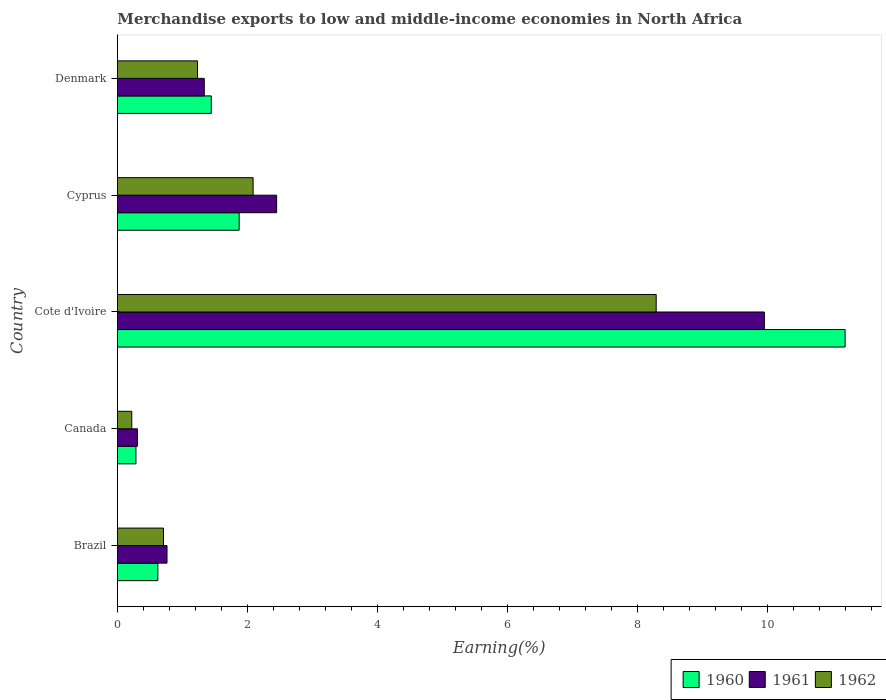How many different coloured bars are there?
Offer a very short reply. 3. How many bars are there on the 3rd tick from the top?
Provide a succinct answer. 3. How many bars are there on the 1st tick from the bottom?
Your answer should be very brief. 3. What is the label of the 3rd group of bars from the top?
Ensure brevity in your answer.  Cote d'Ivoire. What is the percentage of amount earned from merchandise exports in 1961 in Brazil?
Provide a short and direct response. 0.76. Across all countries, what is the maximum percentage of amount earned from merchandise exports in 1962?
Offer a very short reply. 8.29. Across all countries, what is the minimum percentage of amount earned from merchandise exports in 1962?
Ensure brevity in your answer.  0.22. In which country was the percentage of amount earned from merchandise exports in 1962 maximum?
Offer a very short reply. Cote d'Ivoire. What is the total percentage of amount earned from merchandise exports in 1960 in the graph?
Your answer should be compact. 15.41. What is the difference between the percentage of amount earned from merchandise exports in 1962 in Cote d'Ivoire and that in Denmark?
Offer a terse response. 7.05. What is the difference between the percentage of amount earned from merchandise exports in 1960 in Brazil and the percentage of amount earned from merchandise exports in 1962 in Cote d'Ivoire?
Provide a succinct answer. -7.66. What is the average percentage of amount earned from merchandise exports in 1962 per country?
Provide a short and direct response. 2.51. What is the difference between the percentage of amount earned from merchandise exports in 1961 and percentage of amount earned from merchandise exports in 1960 in Denmark?
Your response must be concise. -0.11. What is the ratio of the percentage of amount earned from merchandise exports in 1961 in Canada to that in Cyprus?
Your answer should be compact. 0.13. Is the percentage of amount earned from merchandise exports in 1962 in Cote d'Ivoire less than that in Cyprus?
Offer a very short reply. No. What is the difference between the highest and the second highest percentage of amount earned from merchandise exports in 1962?
Keep it short and to the point. 6.2. What is the difference between the highest and the lowest percentage of amount earned from merchandise exports in 1962?
Offer a terse response. 8.06. In how many countries, is the percentage of amount earned from merchandise exports in 1962 greater than the average percentage of amount earned from merchandise exports in 1962 taken over all countries?
Provide a short and direct response. 1. Is it the case that in every country, the sum of the percentage of amount earned from merchandise exports in 1960 and percentage of amount earned from merchandise exports in 1962 is greater than the percentage of amount earned from merchandise exports in 1961?
Make the answer very short. Yes. How many bars are there?
Offer a very short reply. 15. How many countries are there in the graph?
Offer a very short reply. 5. Are the values on the major ticks of X-axis written in scientific E-notation?
Offer a very short reply. No. How are the legend labels stacked?
Your answer should be very brief. Horizontal. What is the title of the graph?
Keep it short and to the point. Merchandise exports to low and middle-income economies in North Africa. What is the label or title of the X-axis?
Give a very brief answer. Earning(%). What is the label or title of the Y-axis?
Your answer should be very brief. Country. What is the Earning(%) in 1960 in Brazil?
Your response must be concise. 0.62. What is the Earning(%) in 1961 in Brazil?
Offer a terse response. 0.76. What is the Earning(%) in 1962 in Brazil?
Offer a very short reply. 0.71. What is the Earning(%) of 1960 in Canada?
Ensure brevity in your answer.  0.28. What is the Earning(%) of 1961 in Canada?
Keep it short and to the point. 0.31. What is the Earning(%) of 1962 in Canada?
Give a very brief answer. 0.22. What is the Earning(%) in 1960 in Cote d'Ivoire?
Provide a short and direct response. 11.19. What is the Earning(%) of 1961 in Cote d'Ivoire?
Your answer should be very brief. 9.95. What is the Earning(%) in 1962 in Cote d'Ivoire?
Your answer should be very brief. 8.29. What is the Earning(%) of 1960 in Cyprus?
Your response must be concise. 1.87. What is the Earning(%) in 1961 in Cyprus?
Offer a terse response. 2.45. What is the Earning(%) of 1962 in Cyprus?
Ensure brevity in your answer.  2.09. What is the Earning(%) of 1960 in Denmark?
Provide a short and direct response. 1.44. What is the Earning(%) of 1961 in Denmark?
Offer a terse response. 1.34. What is the Earning(%) of 1962 in Denmark?
Offer a terse response. 1.23. Across all countries, what is the maximum Earning(%) of 1960?
Your answer should be compact. 11.19. Across all countries, what is the maximum Earning(%) of 1961?
Make the answer very short. 9.95. Across all countries, what is the maximum Earning(%) of 1962?
Keep it short and to the point. 8.29. Across all countries, what is the minimum Earning(%) of 1960?
Give a very brief answer. 0.28. Across all countries, what is the minimum Earning(%) in 1961?
Make the answer very short. 0.31. Across all countries, what is the minimum Earning(%) of 1962?
Offer a terse response. 0.22. What is the total Earning(%) in 1960 in the graph?
Provide a succinct answer. 15.41. What is the total Earning(%) of 1961 in the graph?
Give a very brief answer. 14.81. What is the total Earning(%) in 1962 in the graph?
Keep it short and to the point. 12.53. What is the difference between the Earning(%) of 1960 in Brazil and that in Canada?
Provide a succinct answer. 0.34. What is the difference between the Earning(%) in 1961 in Brazil and that in Canada?
Offer a very short reply. 0.45. What is the difference between the Earning(%) in 1962 in Brazil and that in Canada?
Your answer should be compact. 0.49. What is the difference between the Earning(%) of 1960 in Brazil and that in Cote d'Ivoire?
Keep it short and to the point. -10.57. What is the difference between the Earning(%) of 1961 in Brazil and that in Cote d'Ivoire?
Offer a very short reply. -9.19. What is the difference between the Earning(%) in 1962 in Brazil and that in Cote d'Ivoire?
Offer a terse response. -7.58. What is the difference between the Earning(%) in 1960 in Brazil and that in Cyprus?
Ensure brevity in your answer.  -1.25. What is the difference between the Earning(%) of 1961 in Brazil and that in Cyprus?
Ensure brevity in your answer.  -1.69. What is the difference between the Earning(%) of 1962 in Brazil and that in Cyprus?
Keep it short and to the point. -1.38. What is the difference between the Earning(%) in 1960 in Brazil and that in Denmark?
Give a very brief answer. -0.82. What is the difference between the Earning(%) of 1961 in Brazil and that in Denmark?
Offer a very short reply. -0.57. What is the difference between the Earning(%) in 1962 in Brazil and that in Denmark?
Ensure brevity in your answer.  -0.52. What is the difference between the Earning(%) of 1960 in Canada and that in Cote d'Ivoire?
Give a very brief answer. -10.91. What is the difference between the Earning(%) of 1961 in Canada and that in Cote d'Ivoire?
Your answer should be very brief. -9.64. What is the difference between the Earning(%) in 1962 in Canada and that in Cote d'Ivoire?
Your answer should be compact. -8.06. What is the difference between the Earning(%) in 1960 in Canada and that in Cyprus?
Keep it short and to the point. -1.59. What is the difference between the Earning(%) of 1961 in Canada and that in Cyprus?
Provide a succinct answer. -2.14. What is the difference between the Earning(%) in 1962 in Canada and that in Cyprus?
Provide a succinct answer. -1.87. What is the difference between the Earning(%) of 1960 in Canada and that in Denmark?
Give a very brief answer. -1.16. What is the difference between the Earning(%) of 1961 in Canada and that in Denmark?
Your answer should be very brief. -1.03. What is the difference between the Earning(%) in 1962 in Canada and that in Denmark?
Offer a very short reply. -1.01. What is the difference between the Earning(%) of 1960 in Cote d'Ivoire and that in Cyprus?
Your answer should be compact. 9.32. What is the difference between the Earning(%) of 1961 in Cote d'Ivoire and that in Cyprus?
Ensure brevity in your answer.  7.5. What is the difference between the Earning(%) in 1962 in Cote d'Ivoire and that in Cyprus?
Ensure brevity in your answer.  6.2. What is the difference between the Earning(%) of 1960 in Cote d'Ivoire and that in Denmark?
Give a very brief answer. 9.75. What is the difference between the Earning(%) in 1961 in Cote d'Ivoire and that in Denmark?
Provide a short and direct response. 8.61. What is the difference between the Earning(%) in 1962 in Cote d'Ivoire and that in Denmark?
Keep it short and to the point. 7.05. What is the difference between the Earning(%) in 1960 in Cyprus and that in Denmark?
Ensure brevity in your answer.  0.43. What is the difference between the Earning(%) in 1961 in Cyprus and that in Denmark?
Your response must be concise. 1.11. What is the difference between the Earning(%) in 1962 in Cyprus and that in Denmark?
Keep it short and to the point. 0.85. What is the difference between the Earning(%) in 1960 in Brazil and the Earning(%) in 1961 in Canada?
Provide a short and direct response. 0.31. What is the difference between the Earning(%) in 1960 in Brazil and the Earning(%) in 1962 in Canada?
Your response must be concise. 0.4. What is the difference between the Earning(%) in 1961 in Brazil and the Earning(%) in 1962 in Canada?
Your answer should be very brief. 0.54. What is the difference between the Earning(%) in 1960 in Brazil and the Earning(%) in 1961 in Cote d'Ivoire?
Offer a terse response. -9.33. What is the difference between the Earning(%) of 1960 in Brazil and the Earning(%) of 1962 in Cote d'Ivoire?
Your response must be concise. -7.66. What is the difference between the Earning(%) of 1961 in Brazil and the Earning(%) of 1962 in Cote d'Ivoire?
Ensure brevity in your answer.  -7.52. What is the difference between the Earning(%) of 1960 in Brazil and the Earning(%) of 1961 in Cyprus?
Your answer should be compact. -1.83. What is the difference between the Earning(%) in 1960 in Brazil and the Earning(%) in 1962 in Cyprus?
Keep it short and to the point. -1.46. What is the difference between the Earning(%) of 1961 in Brazil and the Earning(%) of 1962 in Cyprus?
Offer a very short reply. -1.32. What is the difference between the Earning(%) of 1960 in Brazil and the Earning(%) of 1961 in Denmark?
Provide a short and direct response. -0.71. What is the difference between the Earning(%) of 1960 in Brazil and the Earning(%) of 1962 in Denmark?
Offer a very short reply. -0.61. What is the difference between the Earning(%) of 1961 in Brazil and the Earning(%) of 1962 in Denmark?
Give a very brief answer. -0.47. What is the difference between the Earning(%) in 1960 in Canada and the Earning(%) in 1961 in Cote d'Ivoire?
Your answer should be very brief. -9.66. What is the difference between the Earning(%) of 1960 in Canada and the Earning(%) of 1962 in Cote d'Ivoire?
Keep it short and to the point. -8. What is the difference between the Earning(%) in 1961 in Canada and the Earning(%) in 1962 in Cote d'Ivoire?
Make the answer very short. -7.98. What is the difference between the Earning(%) of 1960 in Canada and the Earning(%) of 1961 in Cyprus?
Give a very brief answer. -2.16. What is the difference between the Earning(%) in 1960 in Canada and the Earning(%) in 1962 in Cyprus?
Offer a very short reply. -1.8. What is the difference between the Earning(%) of 1961 in Canada and the Earning(%) of 1962 in Cyprus?
Ensure brevity in your answer.  -1.78. What is the difference between the Earning(%) in 1960 in Canada and the Earning(%) in 1961 in Denmark?
Ensure brevity in your answer.  -1.05. What is the difference between the Earning(%) of 1960 in Canada and the Earning(%) of 1962 in Denmark?
Keep it short and to the point. -0.95. What is the difference between the Earning(%) of 1961 in Canada and the Earning(%) of 1962 in Denmark?
Keep it short and to the point. -0.92. What is the difference between the Earning(%) in 1960 in Cote d'Ivoire and the Earning(%) in 1961 in Cyprus?
Your response must be concise. 8.74. What is the difference between the Earning(%) in 1960 in Cote d'Ivoire and the Earning(%) in 1962 in Cyprus?
Keep it short and to the point. 9.1. What is the difference between the Earning(%) of 1961 in Cote d'Ivoire and the Earning(%) of 1962 in Cyprus?
Give a very brief answer. 7.86. What is the difference between the Earning(%) in 1960 in Cote d'Ivoire and the Earning(%) in 1961 in Denmark?
Give a very brief answer. 9.86. What is the difference between the Earning(%) of 1960 in Cote d'Ivoire and the Earning(%) of 1962 in Denmark?
Offer a terse response. 9.96. What is the difference between the Earning(%) in 1961 in Cote d'Ivoire and the Earning(%) in 1962 in Denmark?
Provide a succinct answer. 8.72. What is the difference between the Earning(%) in 1960 in Cyprus and the Earning(%) in 1961 in Denmark?
Offer a very short reply. 0.54. What is the difference between the Earning(%) in 1960 in Cyprus and the Earning(%) in 1962 in Denmark?
Keep it short and to the point. 0.64. What is the difference between the Earning(%) in 1961 in Cyprus and the Earning(%) in 1962 in Denmark?
Your answer should be very brief. 1.22. What is the average Earning(%) of 1960 per country?
Give a very brief answer. 3.08. What is the average Earning(%) of 1961 per country?
Ensure brevity in your answer.  2.96. What is the average Earning(%) of 1962 per country?
Your answer should be compact. 2.51. What is the difference between the Earning(%) of 1960 and Earning(%) of 1961 in Brazil?
Your answer should be compact. -0.14. What is the difference between the Earning(%) in 1960 and Earning(%) in 1962 in Brazil?
Your answer should be very brief. -0.09. What is the difference between the Earning(%) in 1961 and Earning(%) in 1962 in Brazil?
Your response must be concise. 0.05. What is the difference between the Earning(%) in 1960 and Earning(%) in 1961 in Canada?
Your answer should be compact. -0.02. What is the difference between the Earning(%) of 1960 and Earning(%) of 1962 in Canada?
Give a very brief answer. 0.06. What is the difference between the Earning(%) in 1961 and Earning(%) in 1962 in Canada?
Your answer should be very brief. 0.09. What is the difference between the Earning(%) in 1960 and Earning(%) in 1961 in Cote d'Ivoire?
Your response must be concise. 1.24. What is the difference between the Earning(%) of 1960 and Earning(%) of 1962 in Cote d'Ivoire?
Provide a short and direct response. 2.91. What is the difference between the Earning(%) in 1961 and Earning(%) in 1962 in Cote d'Ivoire?
Make the answer very short. 1.66. What is the difference between the Earning(%) in 1960 and Earning(%) in 1961 in Cyprus?
Offer a terse response. -0.58. What is the difference between the Earning(%) in 1960 and Earning(%) in 1962 in Cyprus?
Your answer should be very brief. -0.21. What is the difference between the Earning(%) in 1961 and Earning(%) in 1962 in Cyprus?
Make the answer very short. 0.36. What is the difference between the Earning(%) in 1960 and Earning(%) in 1961 in Denmark?
Provide a short and direct response. 0.11. What is the difference between the Earning(%) in 1960 and Earning(%) in 1962 in Denmark?
Give a very brief answer. 0.21. What is the difference between the Earning(%) in 1961 and Earning(%) in 1962 in Denmark?
Make the answer very short. 0.1. What is the ratio of the Earning(%) of 1960 in Brazil to that in Canada?
Provide a succinct answer. 2.18. What is the ratio of the Earning(%) in 1961 in Brazil to that in Canada?
Offer a terse response. 2.48. What is the ratio of the Earning(%) of 1962 in Brazil to that in Canada?
Offer a terse response. 3.21. What is the ratio of the Earning(%) in 1960 in Brazil to that in Cote d'Ivoire?
Your response must be concise. 0.06. What is the ratio of the Earning(%) of 1961 in Brazil to that in Cote d'Ivoire?
Provide a short and direct response. 0.08. What is the ratio of the Earning(%) in 1962 in Brazil to that in Cote d'Ivoire?
Keep it short and to the point. 0.09. What is the ratio of the Earning(%) in 1960 in Brazil to that in Cyprus?
Provide a short and direct response. 0.33. What is the ratio of the Earning(%) in 1961 in Brazil to that in Cyprus?
Offer a terse response. 0.31. What is the ratio of the Earning(%) of 1962 in Brazil to that in Cyprus?
Offer a terse response. 0.34. What is the ratio of the Earning(%) of 1960 in Brazil to that in Denmark?
Offer a very short reply. 0.43. What is the ratio of the Earning(%) in 1961 in Brazil to that in Denmark?
Ensure brevity in your answer.  0.57. What is the ratio of the Earning(%) of 1962 in Brazil to that in Denmark?
Give a very brief answer. 0.57. What is the ratio of the Earning(%) of 1960 in Canada to that in Cote d'Ivoire?
Provide a short and direct response. 0.03. What is the ratio of the Earning(%) in 1961 in Canada to that in Cote d'Ivoire?
Offer a terse response. 0.03. What is the ratio of the Earning(%) of 1962 in Canada to that in Cote d'Ivoire?
Offer a very short reply. 0.03. What is the ratio of the Earning(%) of 1960 in Canada to that in Cyprus?
Provide a succinct answer. 0.15. What is the ratio of the Earning(%) in 1961 in Canada to that in Cyprus?
Give a very brief answer. 0.13. What is the ratio of the Earning(%) of 1962 in Canada to that in Cyprus?
Offer a very short reply. 0.11. What is the ratio of the Earning(%) of 1960 in Canada to that in Denmark?
Your response must be concise. 0.2. What is the ratio of the Earning(%) in 1961 in Canada to that in Denmark?
Ensure brevity in your answer.  0.23. What is the ratio of the Earning(%) in 1962 in Canada to that in Denmark?
Provide a succinct answer. 0.18. What is the ratio of the Earning(%) in 1960 in Cote d'Ivoire to that in Cyprus?
Provide a short and direct response. 5.98. What is the ratio of the Earning(%) of 1961 in Cote d'Ivoire to that in Cyprus?
Provide a short and direct response. 4.06. What is the ratio of the Earning(%) in 1962 in Cote d'Ivoire to that in Cyprus?
Provide a short and direct response. 3.97. What is the ratio of the Earning(%) in 1960 in Cote d'Ivoire to that in Denmark?
Give a very brief answer. 7.75. What is the ratio of the Earning(%) in 1961 in Cote d'Ivoire to that in Denmark?
Your answer should be very brief. 7.45. What is the ratio of the Earning(%) of 1962 in Cote d'Ivoire to that in Denmark?
Ensure brevity in your answer.  6.72. What is the ratio of the Earning(%) of 1960 in Cyprus to that in Denmark?
Keep it short and to the point. 1.3. What is the ratio of the Earning(%) in 1961 in Cyprus to that in Denmark?
Your answer should be very brief. 1.83. What is the ratio of the Earning(%) in 1962 in Cyprus to that in Denmark?
Keep it short and to the point. 1.69. What is the difference between the highest and the second highest Earning(%) of 1960?
Your answer should be very brief. 9.32. What is the difference between the highest and the second highest Earning(%) in 1961?
Provide a short and direct response. 7.5. What is the difference between the highest and the second highest Earning(%) in 1962?
Offer a very short reply. 6.2. What is the difference between the highest and the lowest Earning(%) in 1960?
Offer a terse response. 10.91. What is the difference between the highest and the lowest Earning(%) of 1961?
Give a very brief answer. 9.64. What is the difference between the highest and the lowest Earning(%) of 1962?
Your answer should be very brief. 8.06. 